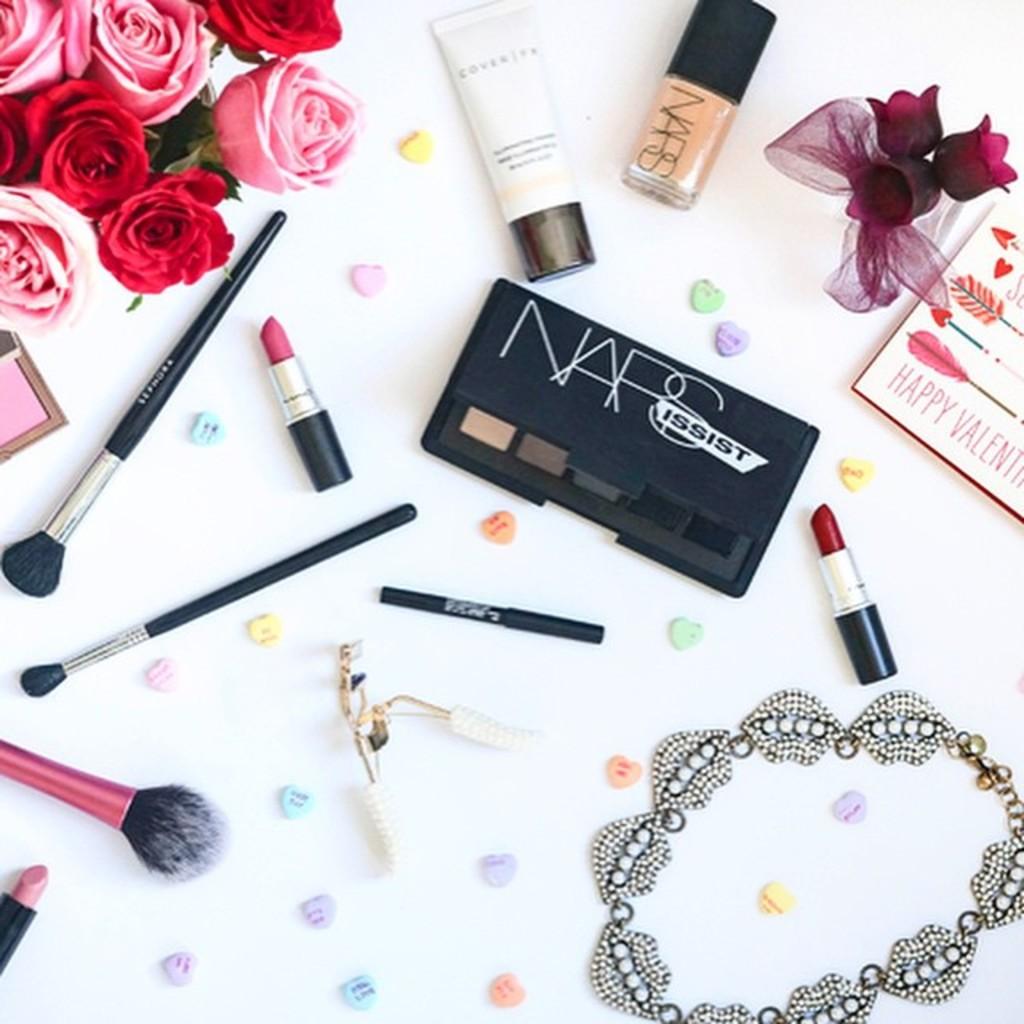What brand of cosmetics are on the table?
Provide a short and direct response. Nars. What color is one of the lipstick?
Your response must be concise. Answering does not require reading text in the image. 